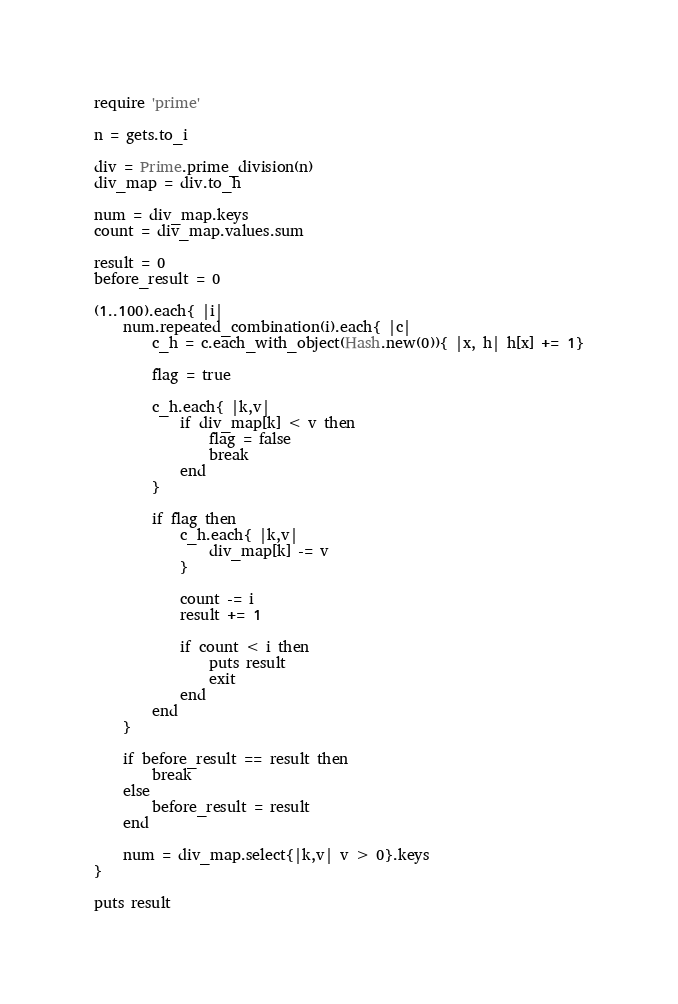Convert code to text. <code><loc_0><loc_0><loc_500><loc_500><_Ruby_>require 'prime'

n = gets.to_i

div = Prime.prime_division(n)
div_map = div.to_h

num = div_map.keys
count = div_map.values.sum

result = 0
before_result = 0

(1..100).each{ |i|
	num.repeated_combination(i).each{ |c|
		c_h = c.each_with_object(Hash.new(0)){ |x, h| h[x] += 1}
		
		flag = true
		
		c_h.each{ |k,v|
			if div_map[k] < v then
				flag = false
				break
			end
		}
		
		if flag then
			c_h.each{ |k,v|
				div_map[k] -= v
			}
			
			count -= i
			result += 1
			
			if count < i then
				puts result
				exit
			end
		end
	}

	if before_result == result then
		break
	else
		before_result = result
	end

	num = div_map.select{|k,v| v > 0}.keys
}

puts result
</code> 